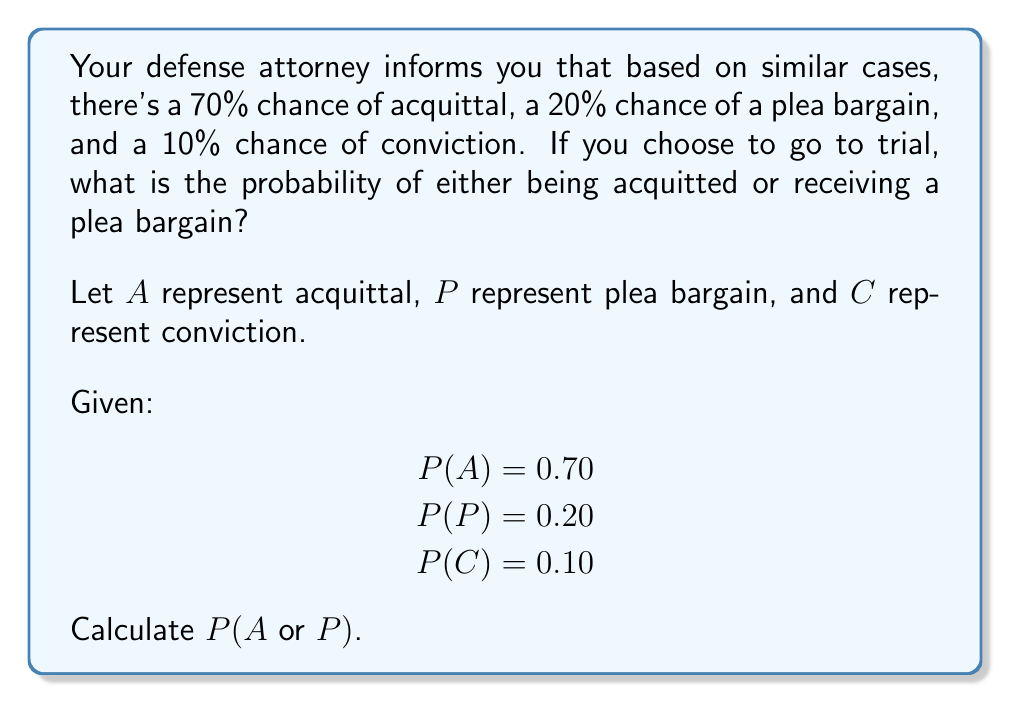Could you help me with this problem? To solve this problem, we'll use the addition rule of probability. Since acquittal and plea bargain are mutually exclusive events (they cannot occur simultaneously), we can simply add their individual probabilities.

Step 1: Identify the given probabilities
P(A) = 0.70 (probability of acquittal)
P(P) = 0.20 (probability of plea bargain)

Step 2: Apply the addition rule for mutually exclusive events
P(A or P) = P(A) + P(P)

Step 3: Substitute the values and calculate
P(A or P) = 0.70 + 0.20 = 0.90

Step 4: Convert to percentage (optional)
0.90 × 100% = 90%

Therefore, the probability of either being acquitted or receiving a plea bargain is 0.90 or 90%.
Answer: 0.90 